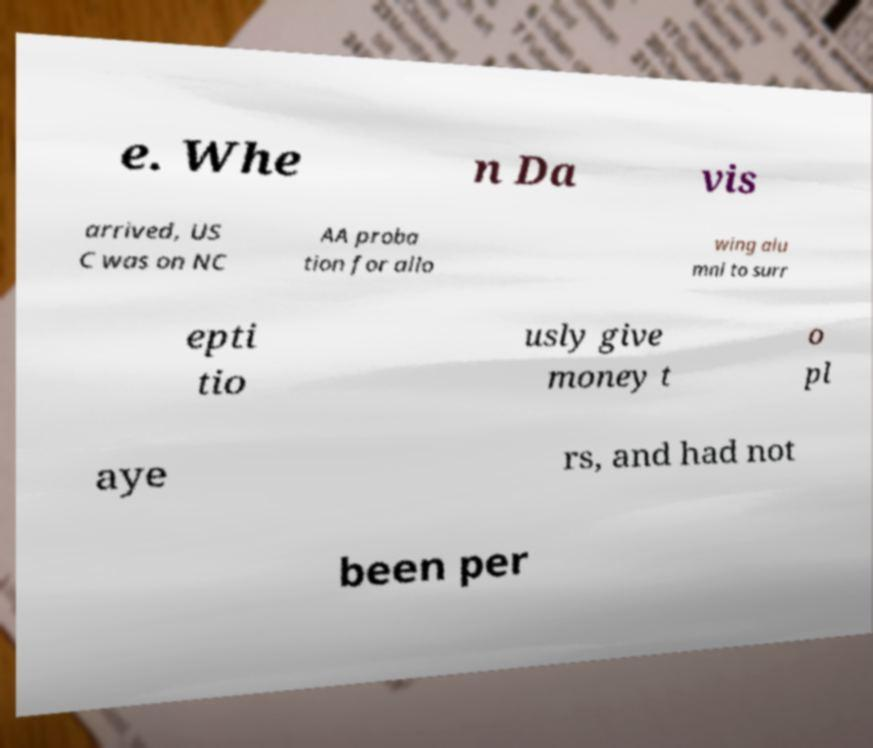For documentation purposes, I need the text within this image transcribed. Could you provide that? e. Whe n Da vis arrived, US C was on NC AA proba tion for allo wing alu mni to surr epti tio usly give money t o pl aye rs, and had not been per 